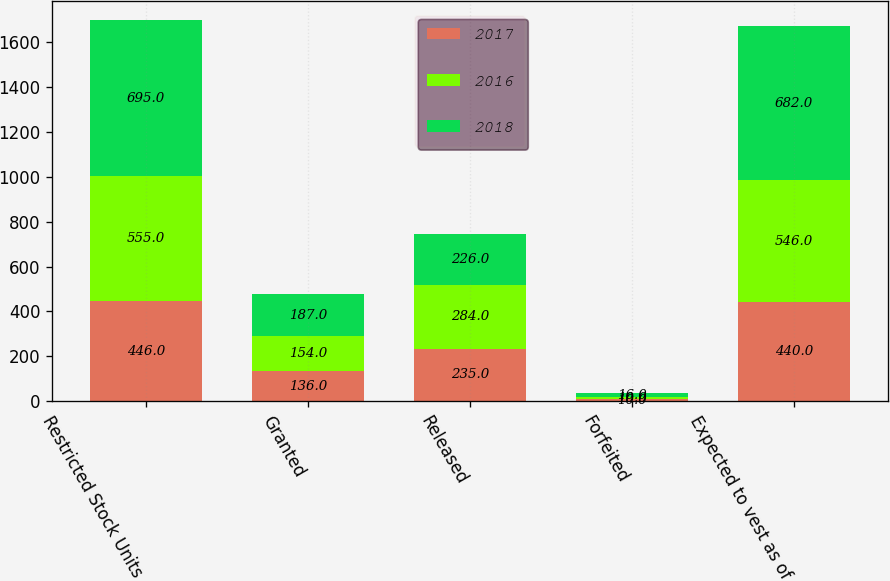<chart> <loc_0><loc_0><loc_500><loc_500><stacked_bar_chart><ecel><fcel>Restricted Stock Units<fcel>Granted<fcel>Released<fcel>Forfeited<fcel>Expected to vest as of<nl><fcel>2017<fcel>446<fcel>136<fcel>235<fcel>10<fcel>440<nl><fcel>2016<fcel>555<fcel>154<fcel>284<fcel>10<fcel>546<nl><fcel>2018<fcel>695<fcel>187<fcel>226<fcel>16<fcel>682<nl></chart> 